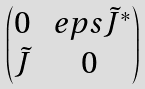Convert formula to latex. <formula><loc_0><loc_0><loc_500><loc_500>\begin{pmatrix} 0 & \ e p s \tilde { J } ^ { * } \\ \tilde { J } & 0 \end{pmatrix}</formula> 